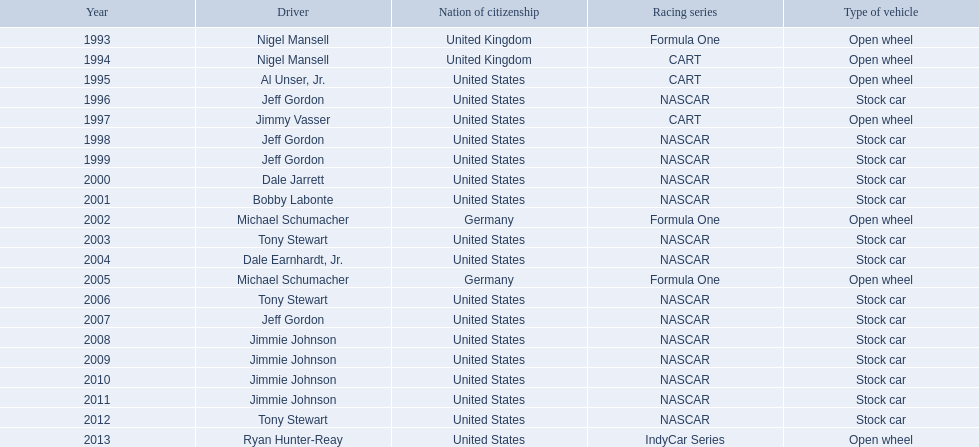During what year(s) was nigel mansel awarded espys? 1993, 1994. During what year(s) was michael schumacher awarded espys? 2002, 2005. During what year(s) was jeff gordon awarded espys? 1996, 1998, 1999, 2007. During what year(s) was al unser jr. awarded espys? 1995. Which driver was granted just one espy award? Al Unser, Jr. 